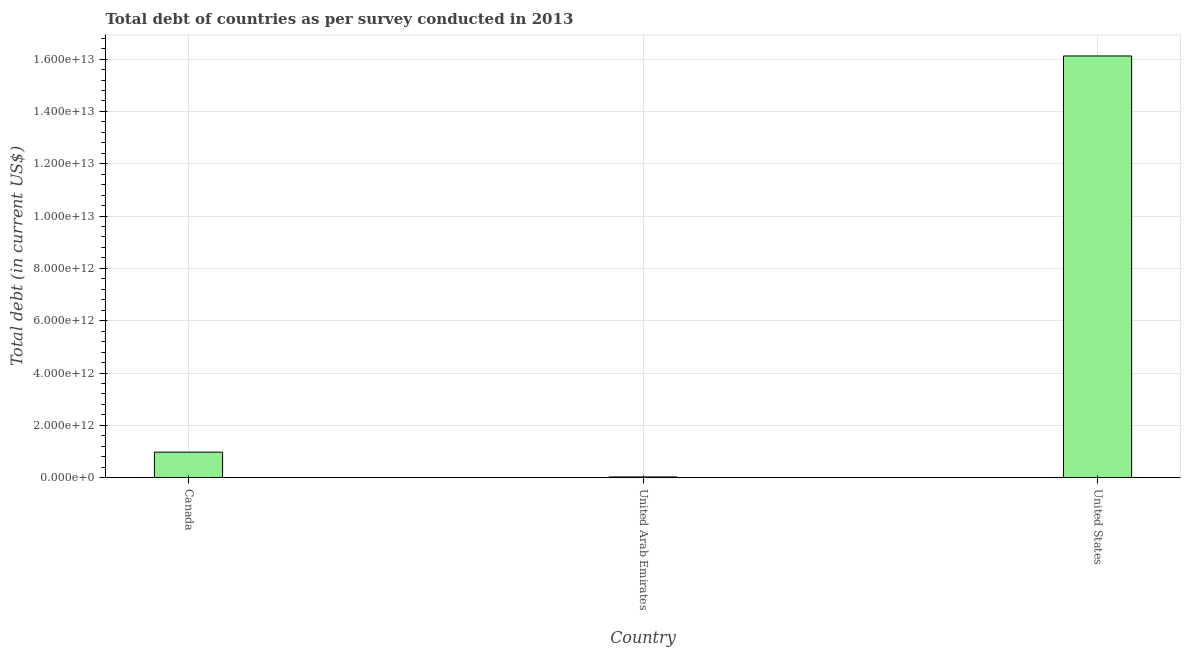What is the title of the graph?
Offer a very short reply. Total debt of countries as per survey conducted in 2013. What is the label or title of the X-axis?
Make the answer very short. Country. What is the label or title of the Y-axis?
Make the answer very short. Total debt (in current US$). What is the total debt in Canada?
Make the answer very short. 9.75e+11. Across all countries, what is the maximum total debt?
Keep it short and to the point. 1.61e+13. Across all countries, what is the minimum total debt?
Provide a succinct answer. 2.71e+1. In which country was the total debt minimum?
Keep it short and to the point. United Arab Emirates. What is the sum of the total debt?
Your response must be concise. 1.71e+13. What is the difference between the total debt in Canada and United Arab Emirates?
Offer a very short reply. 9.48e+11. What is the average total debt per country?
Your answer should be very brief. 5.71e+12. What is the median total debt?
Ensure brevity in your answer.  9.75e+11. In how many countries, is the total debt greater than 16000000000000 US$?
Provide a succinct answer. 1. What is the ratio of the total debt in United Arab Emirates to that in United States?
Ensure brevity in your answer.  0. Is the total debt in United Arab Emirates less than that in United States?
Give a very brief answer. Yes. What is the difference between the highest and the second highest total debt?
Your answer should be very brief. 1.51e+13. Is the sum of the total debt in United Arab Emirates and United States greater than the maximum total debt across all countries?
Keep it short and to the point. Yes. What is the difference between the highest and the lowest total debt?
Give a very brief answer. 1.61e+13. In how many countries, is the total debt greater than the average total debt taken over all countries?
Make the answer very short. 1. How many bars are there?
Your answer should be very brief. 3. Are all the bars in the graph horizontal?
Keep it short and to the point. No. What is the difference between two consecutive major ticks on the Y-axis?
Ensure brevity in your answer.  2.00e+12. Are the values on the major ticks of Y-axis written in scientific E-notation?
Offer a very short reply. Yes. What is the Total debt (in current US$) of Canada?
Offer a very short reply. 9.75e+11. What is the Total debt (in current US$) of United Arab Emirates?
Offer a terse response. 2.71e+1. What is the Total debt (in current US$) of United States?
Keep it short and to the point. 1.61e+13. What is the difference between the Total debt (in current US$) in Canada and United Arab Emirates?
Give a very brief answer. 9.48e+11. What is the difference between the Total debt (in current US$) in Canada and United States?
Make the answer very short. -1.51e+13. What is the difference between the Total debt (in current US$) in United Arab Emirates and United States?
Keep it short and to the point. -1.61e+13. What is the ratio of the Total debt (in current US$) in Canada to that in United Arab Emirates?
Offer a very short reply. 35.96. What is the ratio of the Total debt (in current US$) in Canada to that in United States?
Provide a short and direct response. 0.06. What is the ratio of the Total debt (in current US$) in United Arab Emirates to that in United States?
Offer a very short reply. 0. 